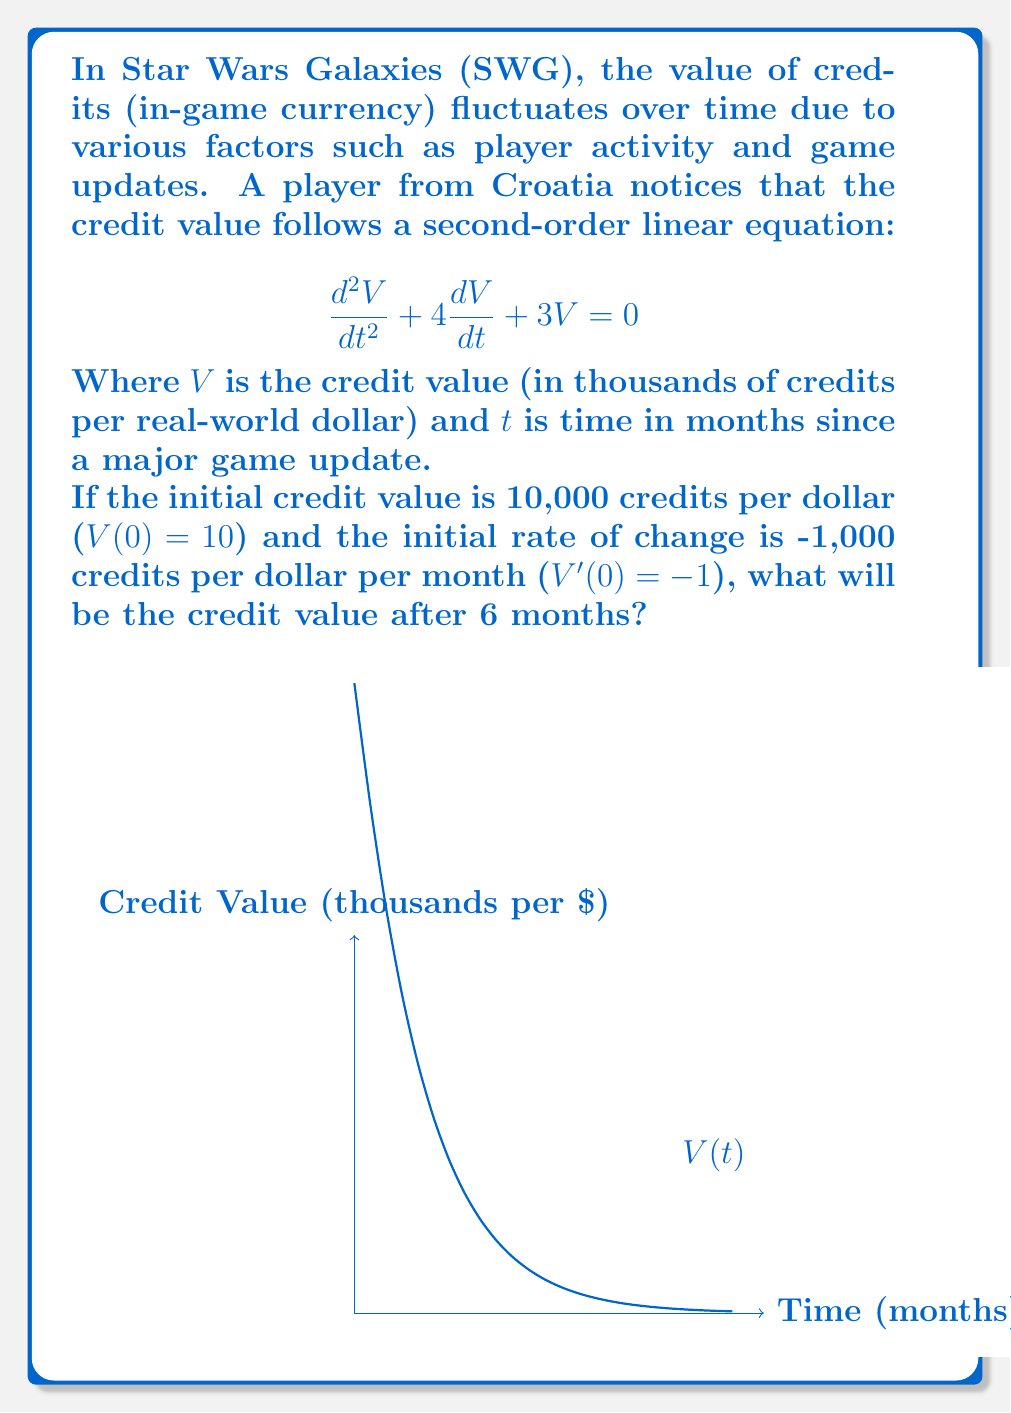Show me your answer to this math problem. Let's solve this step-by-step:

1) The characteristic equation for this second-order linear equation is:
   $$r^2 + 4r + 3 = 0$$

2) Solving this equation:
   $$(r+1)(r+3) = 0$$
   $r = -1$ or $r = -3$

3) The general solution is:
   $$V(t) = c_1e^{-t} + c_2e^{-3t}$$

4) Using the initial conditions:
   $V(0) = 10$, so $c_1 + c_2 = 10$
   $V'(0) = -1$, so $-c_1 - 3c_2 = -1$

5) Solving these equations:
   $c_1 = 11$ and $c_2 = -1$

6) Therefore, the particular solution is:
   $$V(t) = 11e^{-t} - e^{-3t}$$

7) To find the value after 6 months, we calculate $V(6)$:
   $$V(6) = 11e^{-6} - e^{-18}$$

8) Using a calculator:
   $$V(6) \approx 11(0.002479) - 0.000000000015 \approx 0.02727$$

9) Converting back to credits:
   $0.02727 * 1000 = 27.27$ credits per dollar
Answer: $27.27$ credits per dollar 